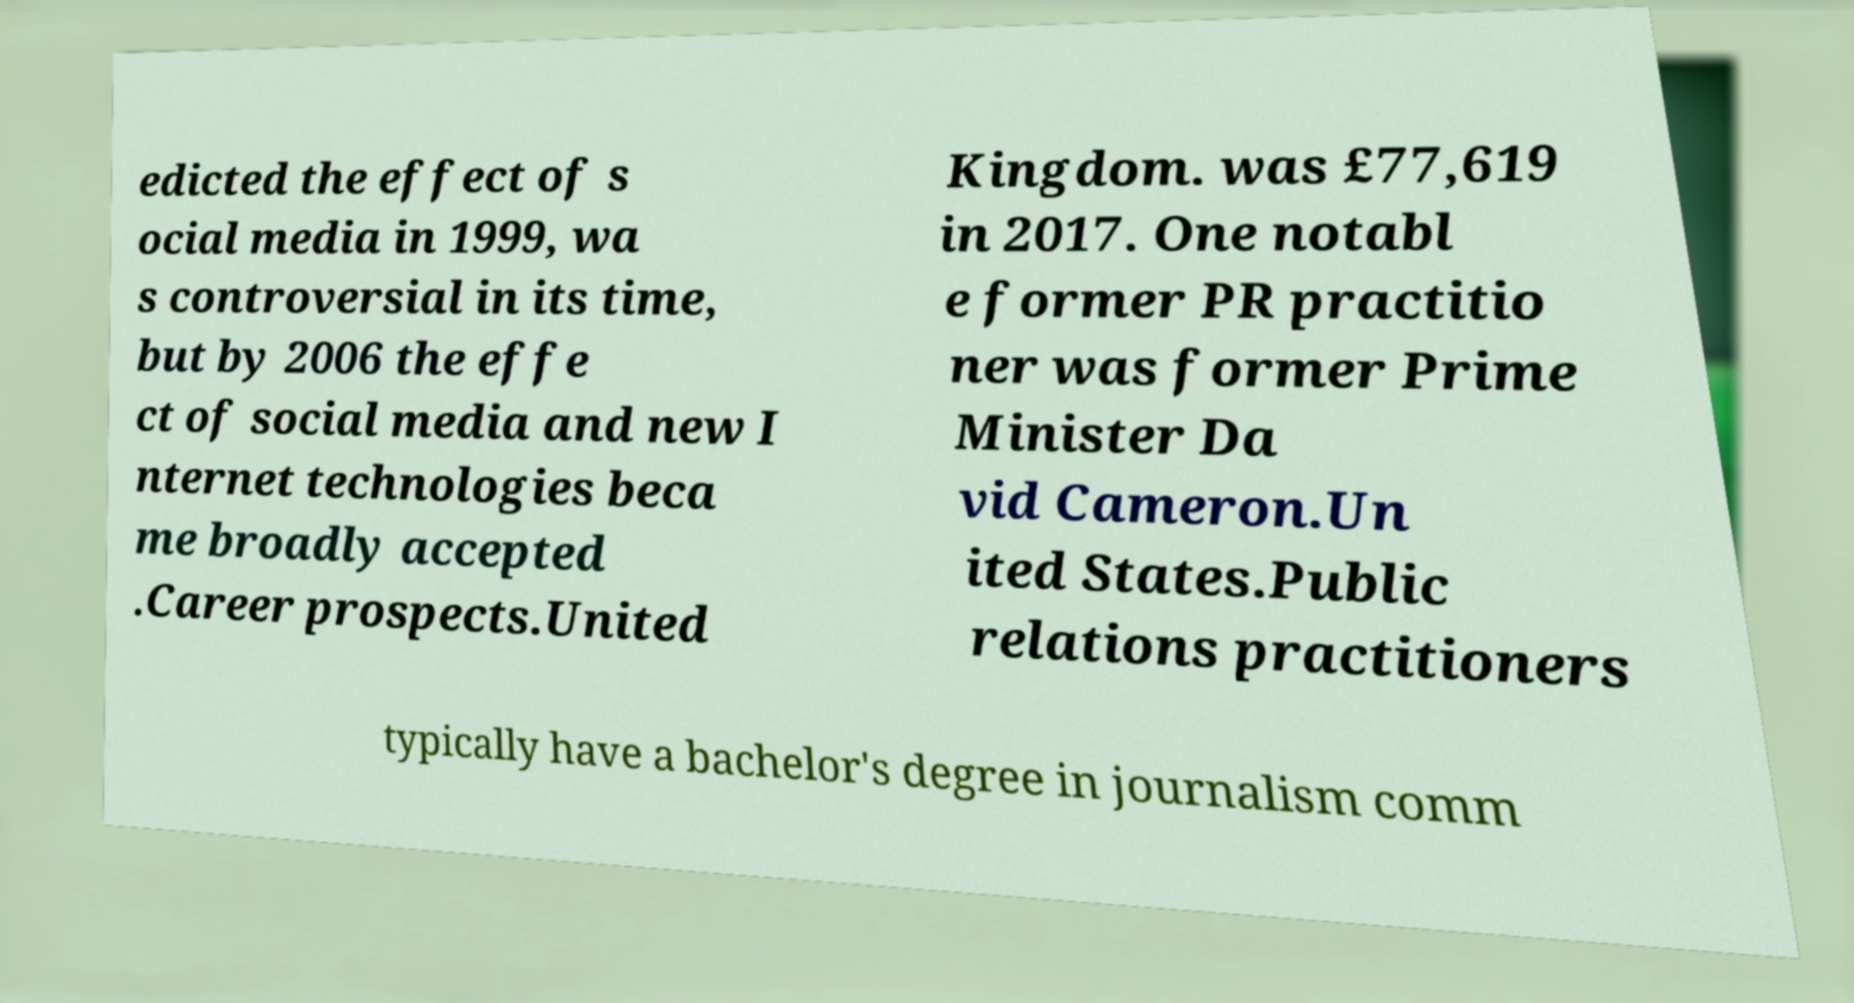For documentation purposes, I need the text within this image transcribed. Could you provide that? edicted the effect of s ocial media in 1999, wa s controversial in its time, but by 2006 the effe ct of social media and new I nternet technologies beca me broadly accepted .Career prospects.United Kingdom. was £77,619 in 2017. One notabl e former PR practitio ner was former Prime Minister Da vid Cameron.Un ited States.Public relations practitioners typically have a bachelor's degree in journalism comm 